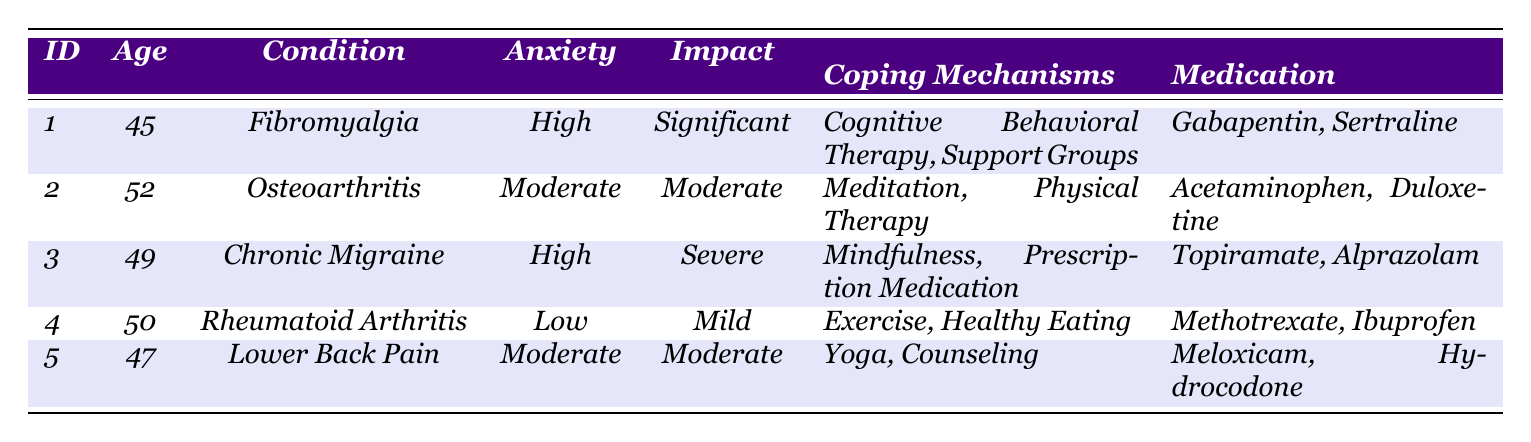What is the age of the respondent with the chronic pain condition of Fibromyalgia? The table shows that the respondent with Fibromyalgia has an age of 45 years.
Answer: 45 How many respondents reported a "High" anxiety level? By looking through the anxiety levels, two respondents (IDs 1 and 3) reported a "High" anxiety level.
Answer: 2 What chronic pain condition does the respondent aged 50 have? The table indicates that the respondent aged 50 has Rheumatoid Arthritis as their chronic pain condition.
Answer: Rheumatoid Arthritis What medications are reported by the respondent with "Moderate" mental health impact? The respondents with "Moderate" mental health impact are IDs 2 and 5. ID 2 takes Acetaminophen and Duloxetine, while ID 5 takes Meloxicam and Hydrocodone.
Answer: Acetaminophen, Duloxetine; Meloxicam, Hydrocodone Is there any respondent who has a "Low" anxiety level? Yes, the table indicates that the respondent with ID 4 has a "Low" anxiety level.
Answer: Yes What is the average age of respondents who report a "Significant" mental health impact? The only respondent with "Significant" mental health impact is ID 1, who is 45 years old, so the average age is 45.
Answer: 45 Which coping mechanism is most commonly cited among respondents? The coping mechanisms listed for each respondent are unique; Private and communal strategies such as Cognitive Behavioral Therapy, Meditation, and Exercise are all mentioned but not repeated across respondents. Thus, none stand out as the most common.
Answer: None common How does the anxiety level correlate with the mental health impact among the respondents? Analyzing the data, both respondents with "High" anxiety also reported a significant impact on mental health (ID 1: Significant, ID 3: Severe). The respondent with "Low" anxiety (ID 4) reported a "Mild" impact. The pattern shows higher anxiety coincides with a greater impact.
Answer: Higher anxiety correlates with greater impact What is the difference in the age of the youngest and oldest respondents? The youngest respondent is 45 years old (ID 1) and the oldest is 52 years old (ID 2). The difference in their ages is 52 - 45 = 7 years.
Answer: 7 years What percentage of respondents uses "Support Groups" as a coping mechanism? Only one of the five respondents (ID 1) uses "Support Groups." Therefore, the percentage is (1/5) * 100 = 20%.
Answer: 20% 